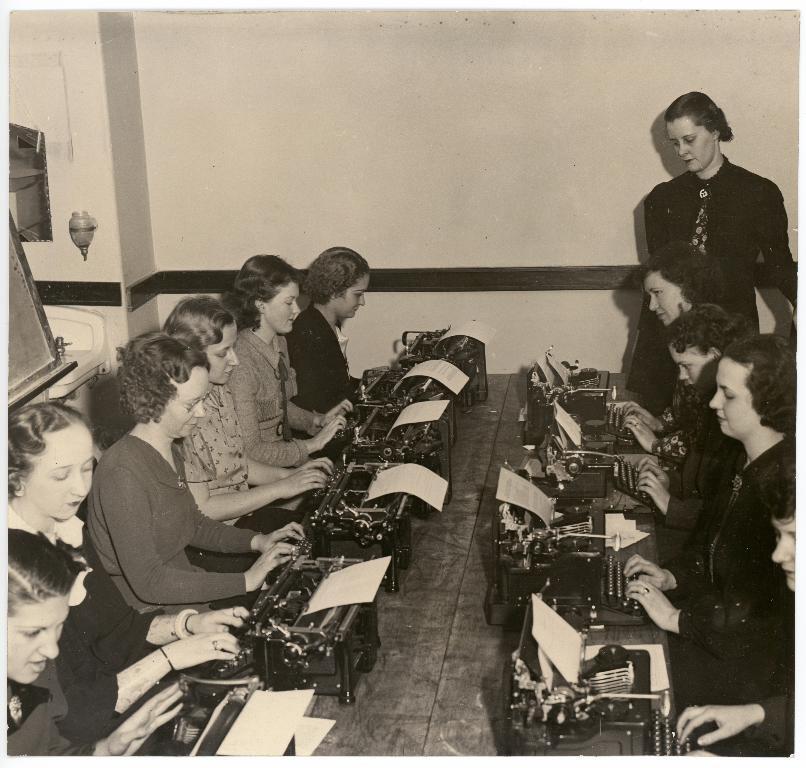Please provide a concise description of this image. In this image we can see a group of people sitting on the chairs. In the foreground we can see some machines and papers placed on the surface. On the left side we can see a sink, a mirror and a lamp on a wall. On the right side we can see a woman standing. 